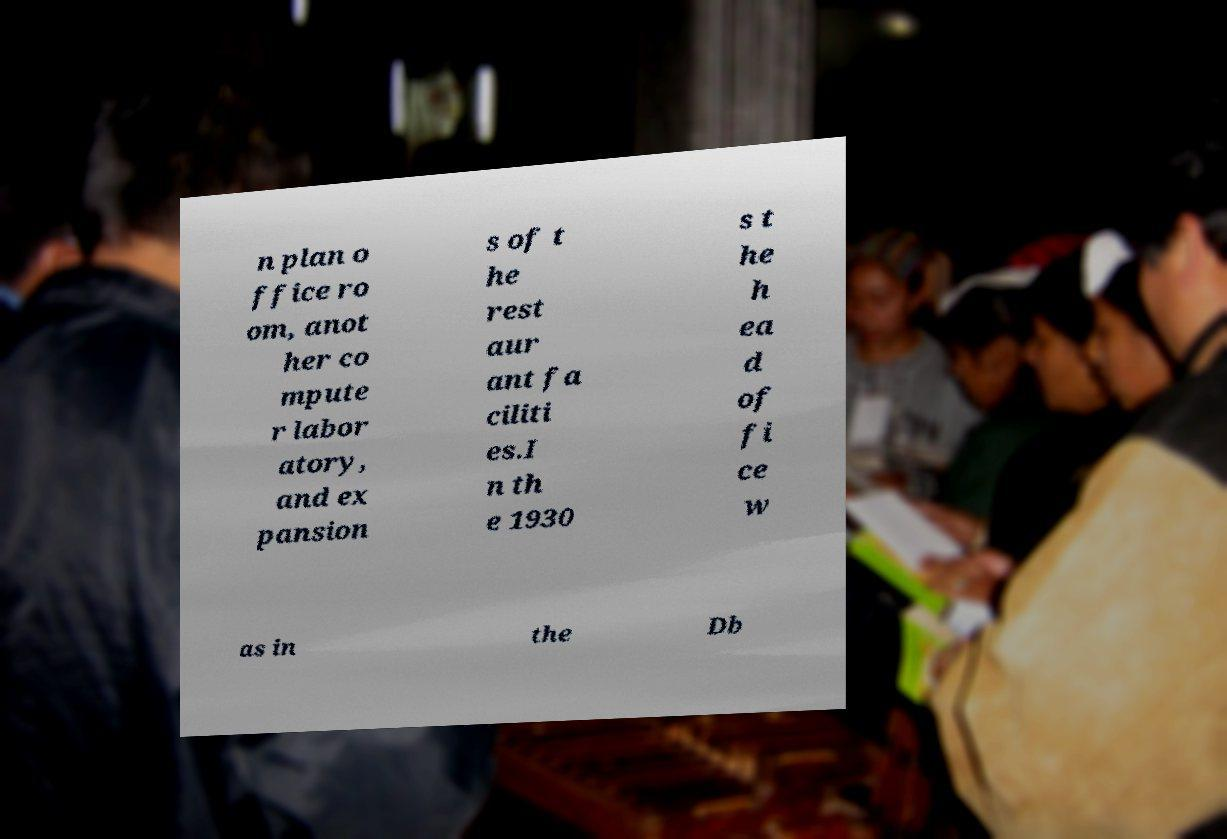Can you accurately transcribe the text from the provided image for me? n plan o ffice ro om, anot her co mpute r labor atory, and ex pansion s of t he rest aur ant fa ciliti es.I n th e 1930 s t he h ea d of fi ce w as in the Db 